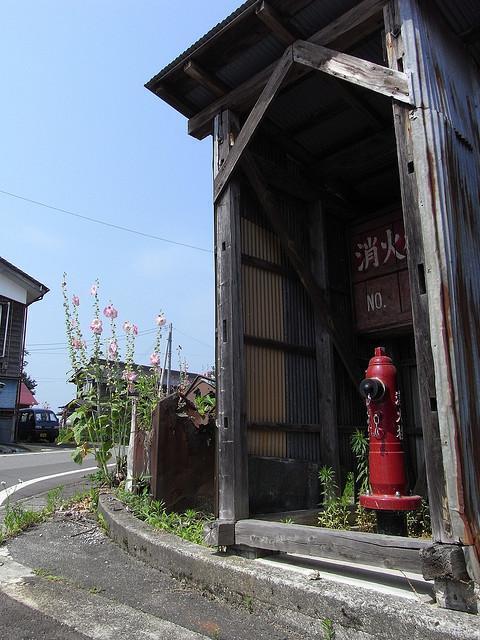How many people are snowboarding in the photo?
Give a very brief answer. 0. 